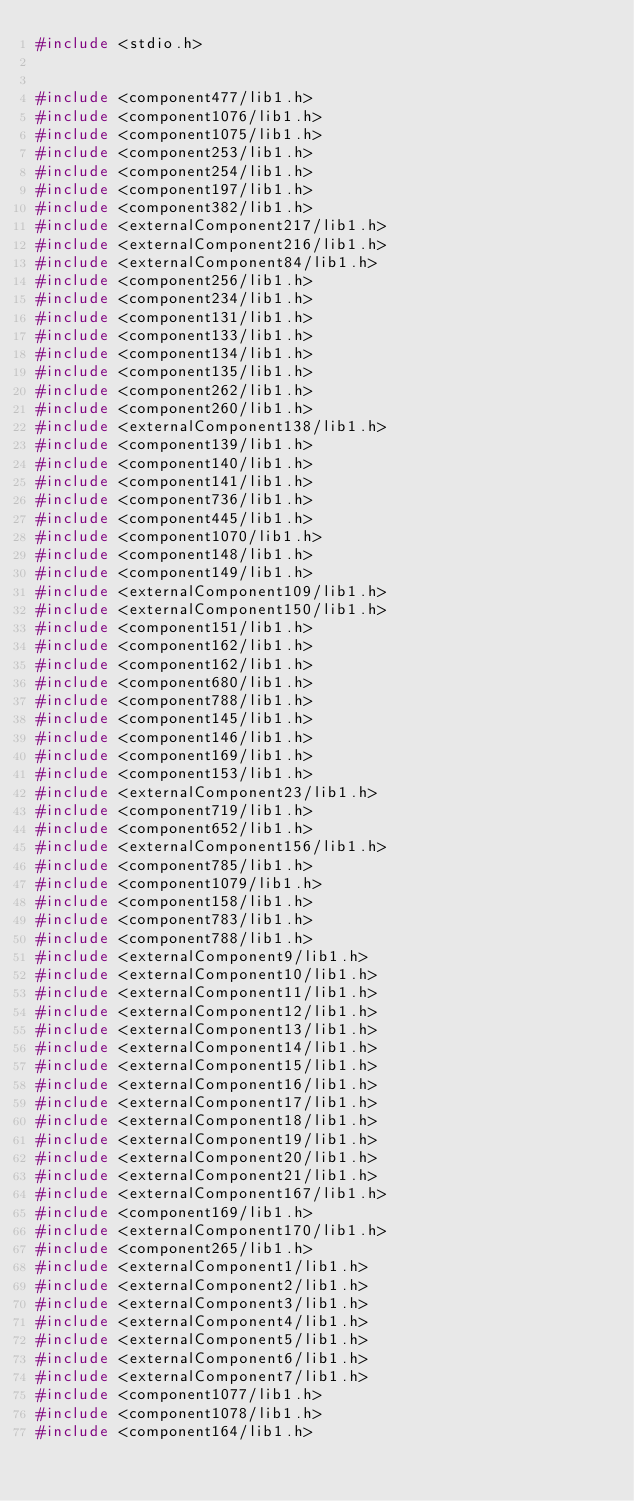<code> <loc_0><loc_0><loc_500><loc_500><_C++_>#include <stdio.h>


#include <component477/lib1.h>
#include <component1076/lib1.h>
#include <component1075/lib1.h>
#include <component253/lib1.h>
#include <component254/lib1.h>
#include <component197/lib1.h>
#include <component382/lib1.h>
#include <externalComponent217/lib1.h>
#include <externalComponent216/lib1.h>
#include <externalComponent84/lib1.h>
#include <component256/lib1.h>
#include <component234/lib1.h>
#include <component131/lib1.h>
#include <component133/lib1.h>
#include <component134/lib1.h>
#include <component135/lib1.h>
#include <component262/lib1.h>
#include <component260/lib1.h>
#include <externalComponent138/lib1.h>
#include <component139/lib1.h>
#include <component140/lib1.h>
#include <component141/lib1.h>
#include <component736/lib1.h>
#include <component445/lib1.h>
#include <component1070/lib1.h>
#include <component148/lib1.h>
#include <component149/lib1.h>
#include <externalComponent109/lib1.h>
#include <externalComponent150/lib1.h>
#include <component151/lib1.h>
#include <component162/lib1.h>
#include <component162/lib1.h>
#include <component680/lib1.h>
#include <component788/lib1.h>
#include <component145/lib1.h>
#include <component146/lib1.h>
#include <component169/lib1.h>
#include <component153/lib1.h>
#include <externalComponent23/lib1.h>
#include <component719/lib1.h>
#include <component652/lib1.h>
#include <externalComponent156/lib1.h>
#include <component785/lib1.h>
#include <component1079/lib1.h>
#include <component158/lib1.h>
#include <component783/lib1.h>
#include <component788/lib1.h>
#include <externalComponent9/lib1.h>
#include <externalComponent10/lib1.h>
#include <externalComponent11/lib1.h>
#include <externalComponent12/lib1.h>
#include <externalComponent13/lib1.h>
#include <externalComponent14/lib1.h>
#include <externalComponent15/lib1.h>
#include <externalComponent16/lib1.h>
#include <externalComponent17/lib1.h>
#include <externalComponent18/lib1.h>
#include <externalComponent19/lib1.h>
#include <externalComponent20/lib1.h>
#include <externalComponent21/lib1.h>
#include <externalComponent167/lib1.h>
#include <component169/lib1.h>
#include <externalComponent170/lib1.h>
#include <component265/lib1.h>
#include <externalComponent1/lib1.h>
#include <externalComponent2/lib1.h>
#include <externalComponent3/lib1.h>
#include <externalComponent4/lib1.h>
#include <externalComponent5/lib1.h>
#include <externalComponent6/lib1.h>
#include <externalComponent7/lib1.h>
#include <component1077/lib1.h>
#include <component1078/lib1.h>
#include <component164/lib1.h></code> 